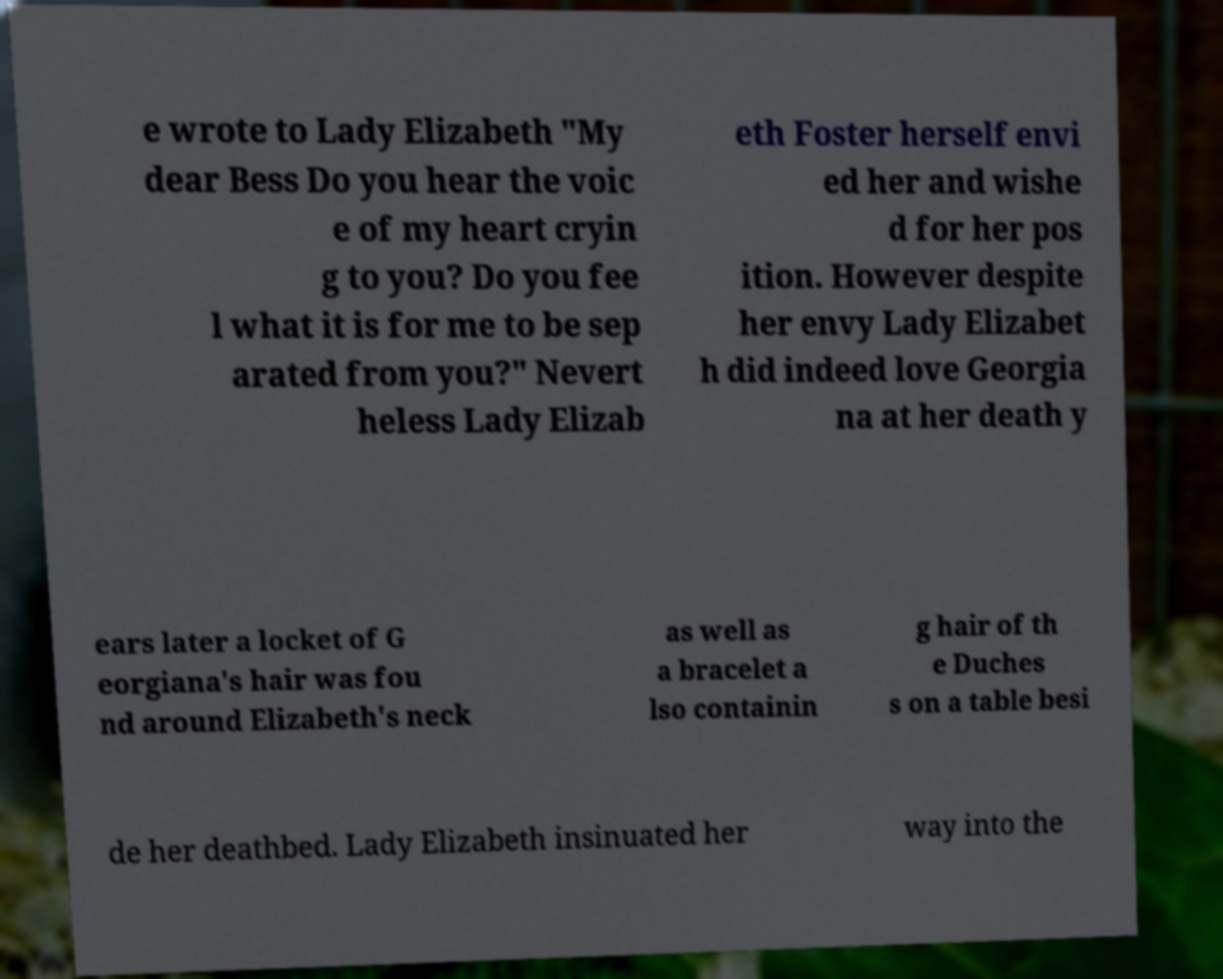Could you assist in decoding the text presented in this image and type it out clearly? e wrote to Lady Elizabeth "My dear Bess Do you hear the voic e of my heart cryin g to you? Do you fee l what it is for me to be sep arated from you?" Nevert heless Lady Elizab eth Foster herself envi ed her and wishe d for her pos ition. However despite her envy Lady Elizabet h did indeed love Georgia na at her death y ears later a locket of G eorgiana's hair was fou nd around Elizabeth's neck as well as a bracelet a lso containin g hair of th e Duches s on a table besi de her deathbed. Lady Elizabeth insinuated her way into the 